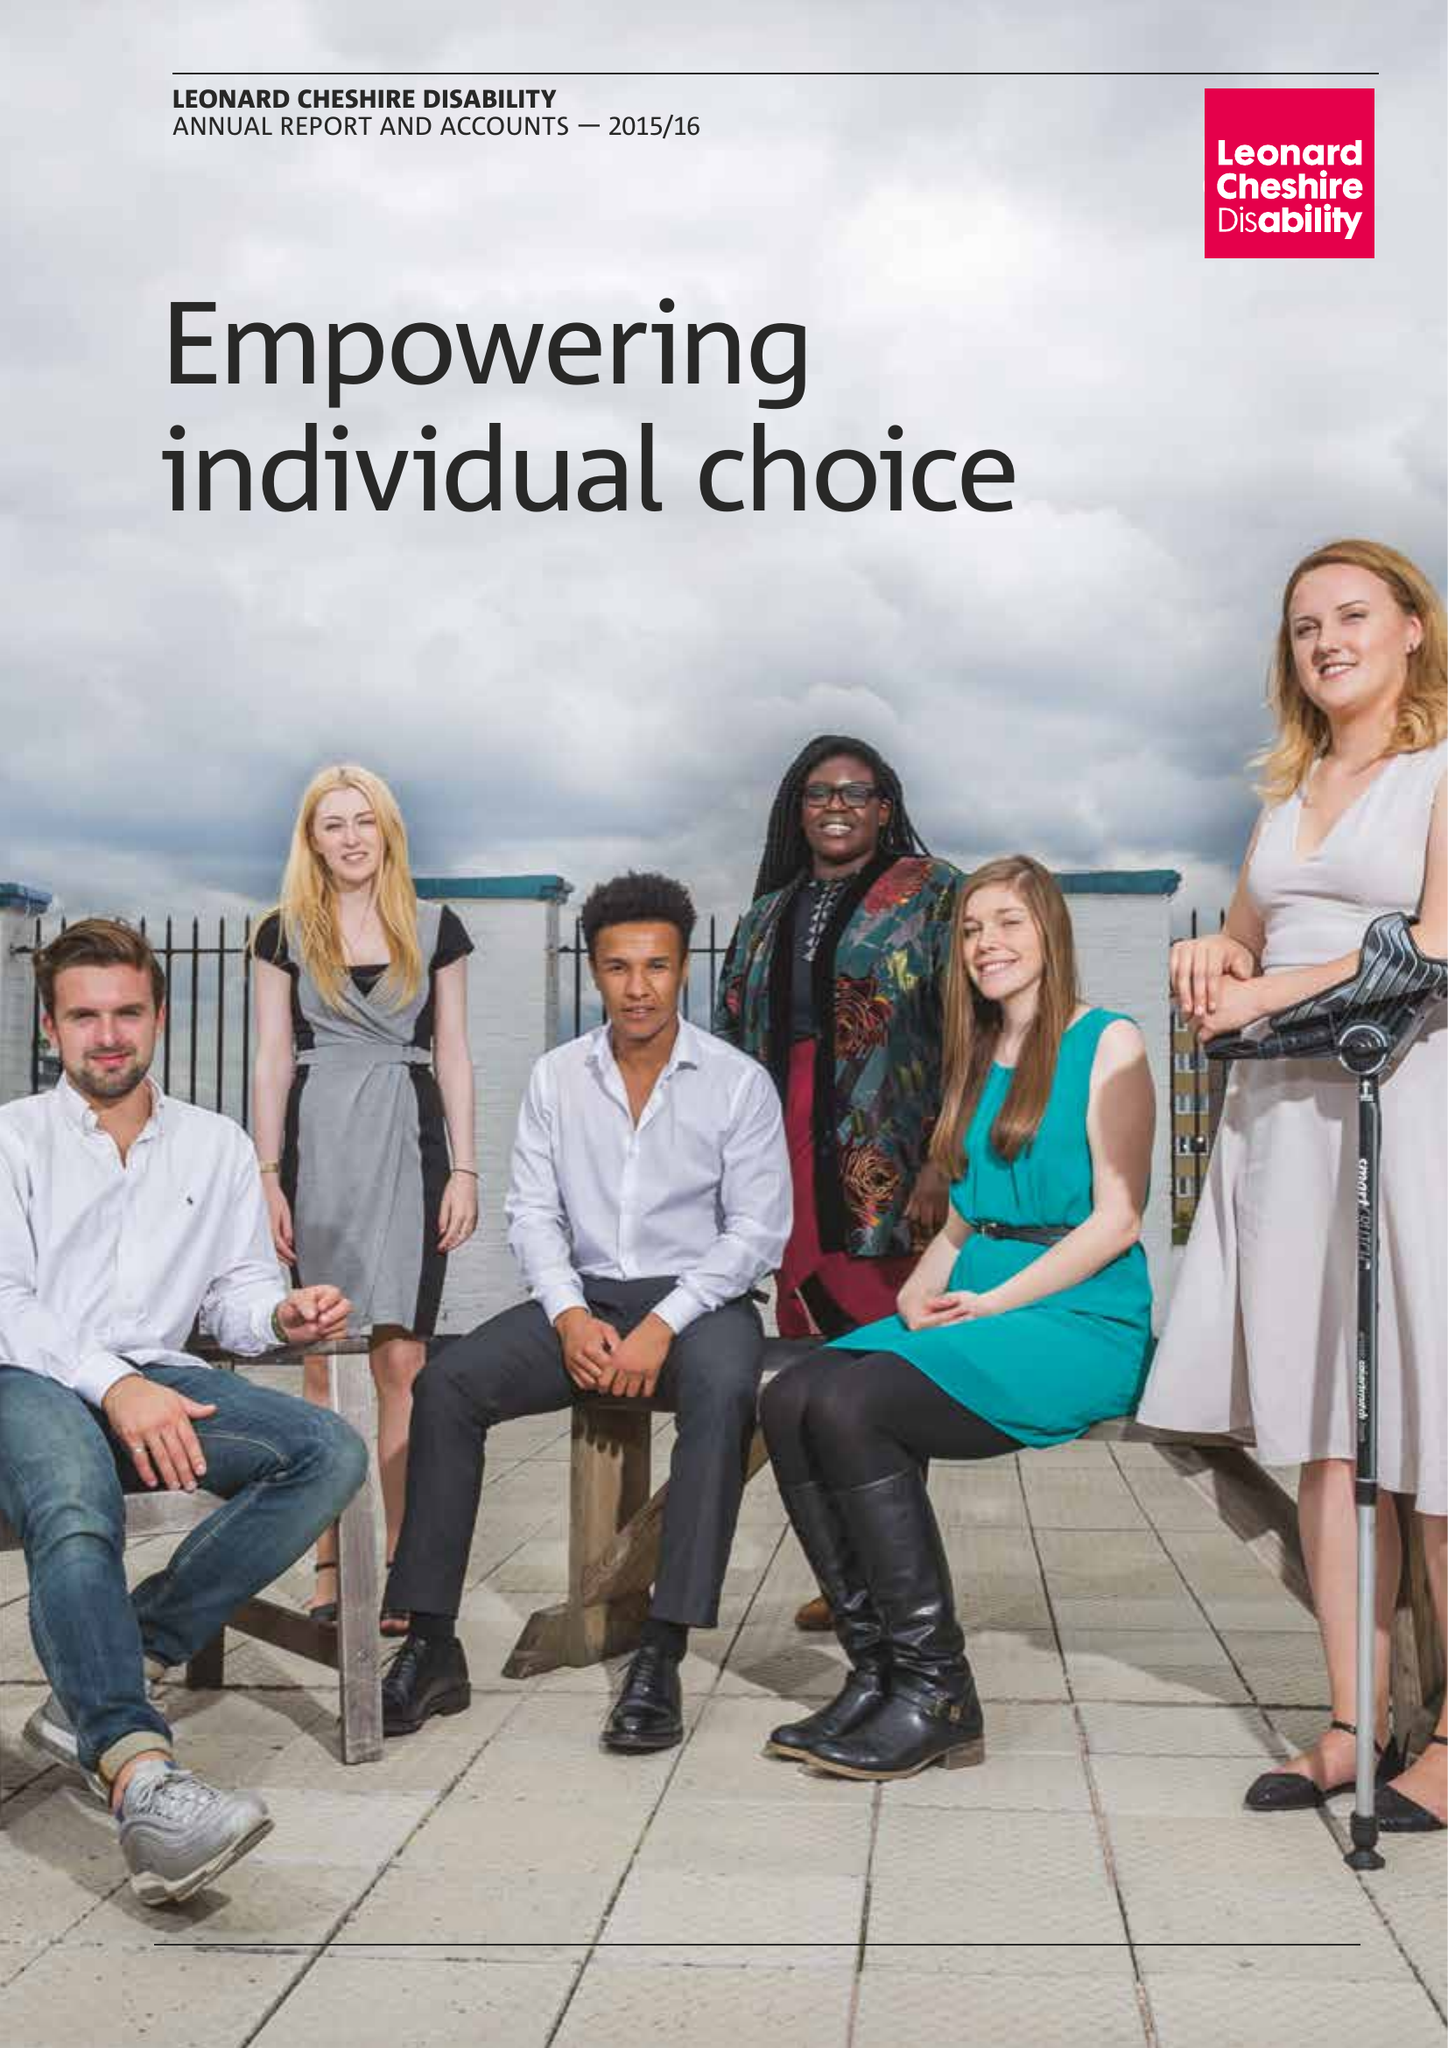What is the value for the charity_name?
Answer the question using a single word or phrase. Leonard Cheshire Disability 